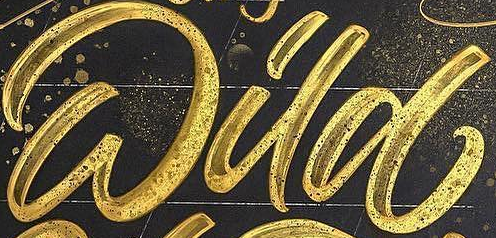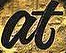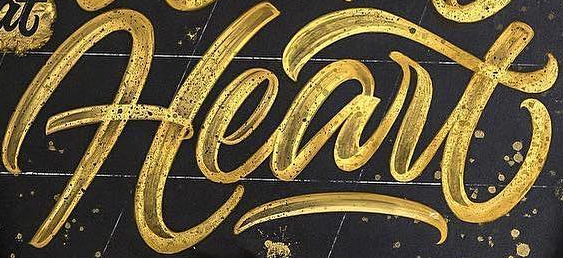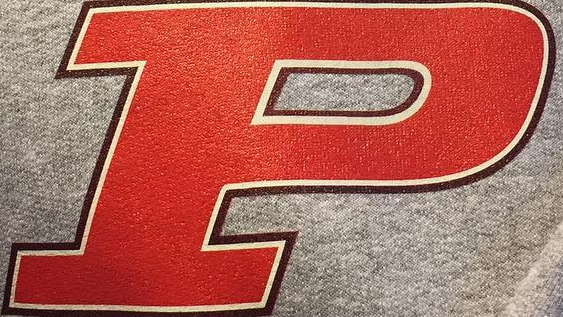Read the text from these images in sequence, separated by a semicolon. Wild; at; Heart; P 